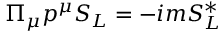<formula> <loc_0><loc_0><loc_500><loc_500>\Pi _ { \mu } p ^ { \mu } S _ { L } = - i m S _ { L } ^ { * }</formula> 